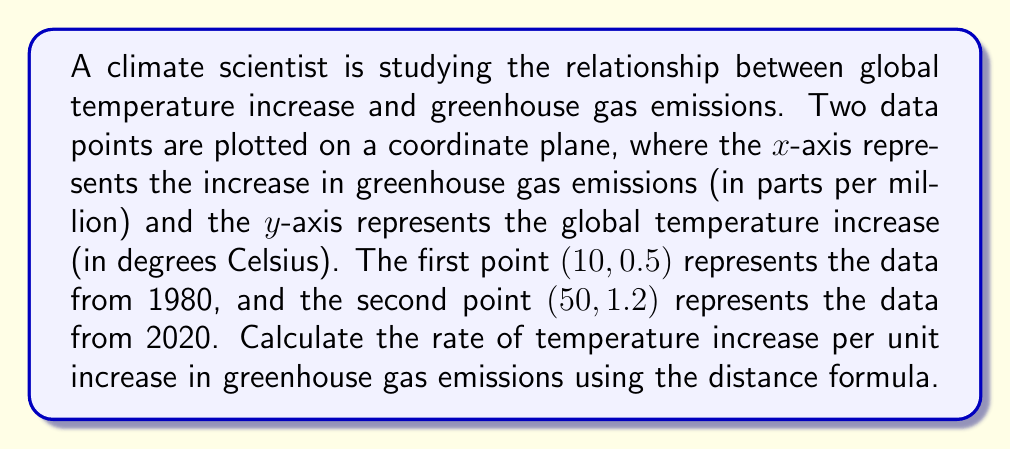Can you solve this math problem? To solve this problem, we'll use the distance formula and the concept of slope to find the rate of temperature increase per unit increase in greenhouse gas emissions.

Step 1: Identify the coordinates of the two points.
Point 1 (1980): $(x_1, y_1) = (10, 0.5)$
Point 2 (2020): $(x_2, y_2) = (50, 1.2)$

Step 2: Use the distance formula to calculate the change in temperature and greenhouse gas emissions.

The distance formula is:
$$d = \sqrt{(x_2 - x_1)^2 + (y_2 - y_1)^2}$$

For the change in greenhouse gas emissions (x-axis):
$$\Delta x = x_2 - x_1 = 50 - 10 = 40 \text{ ppm}$$

For the change in temperature (y-axis):
$$\Delta y = y_2 - y_1 = 1.2 - 0.5 = 0.7 \text{ °C}$$

Step 3: Calculate the rate of temperature increase per unit increase in greenhouse gas emissions.

The rate is equal to the slope of the line connecting these two points:

$$\text{Rate} = \frac{\Delta y}{\Delta x} = \frac{0.7 \text{ °C}}{40 \text{ ppm}} = 0.0175 \text{ °C/ppm}$$

This means for every 1 ppm increase in greenhouse gas emissions, the temperature increases by 0.0175 °C.
Answer: $0.0175 \text{ °C/ppm}$ 